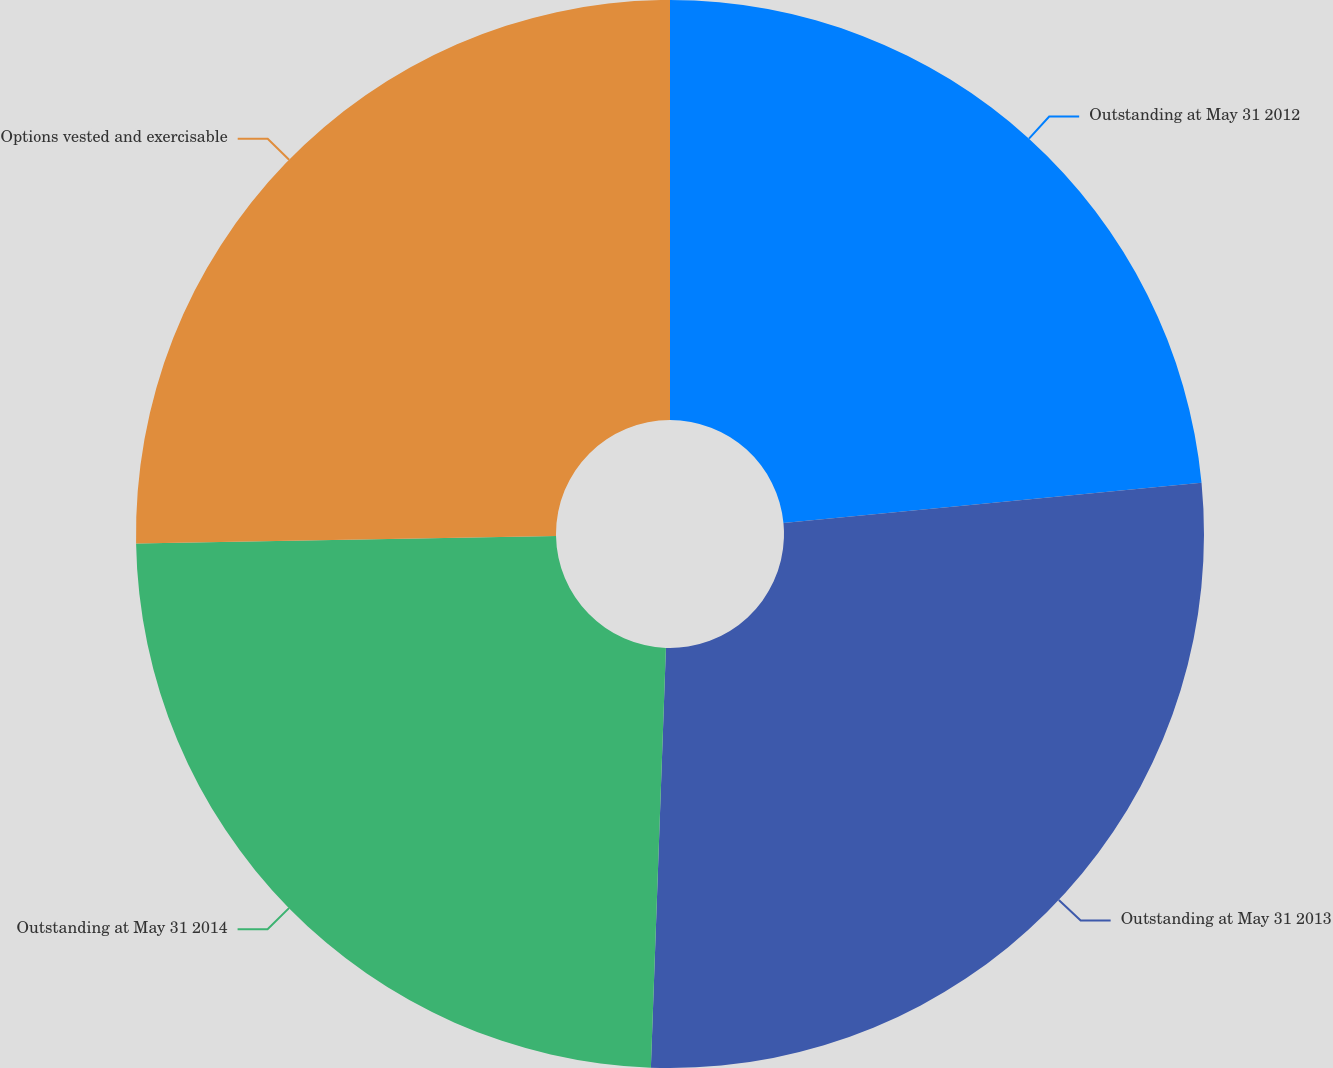Convert chart to OTSL. <chart><loc_0><loc_0><loc_500><loc_500><pie_chart><fcel>Outstanding at May 31 2012<fcel>Outstanding at May 31 2013<fcel>Outstanding at May 31 2014<fcel>Options vested and exercisable<nl><fcel>23.47%<fcel>27.1%<fcel>24.15%<fcel>25.28%<nl></chart> 